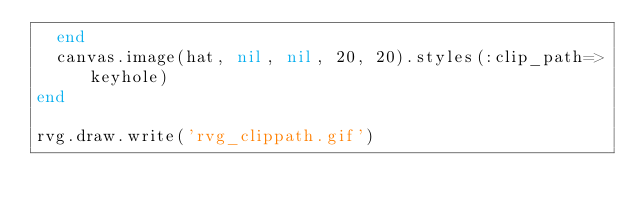Convert code to text. <code><loc_0><loc_0><loc_500><loc_500><_Ruby_>  end
  canvas.image(hat, nil, nil, 20, 20).styles(:clip_path=>keyhole)
end

rvg.draw.write('rvg_clippath.gif')
</code> 